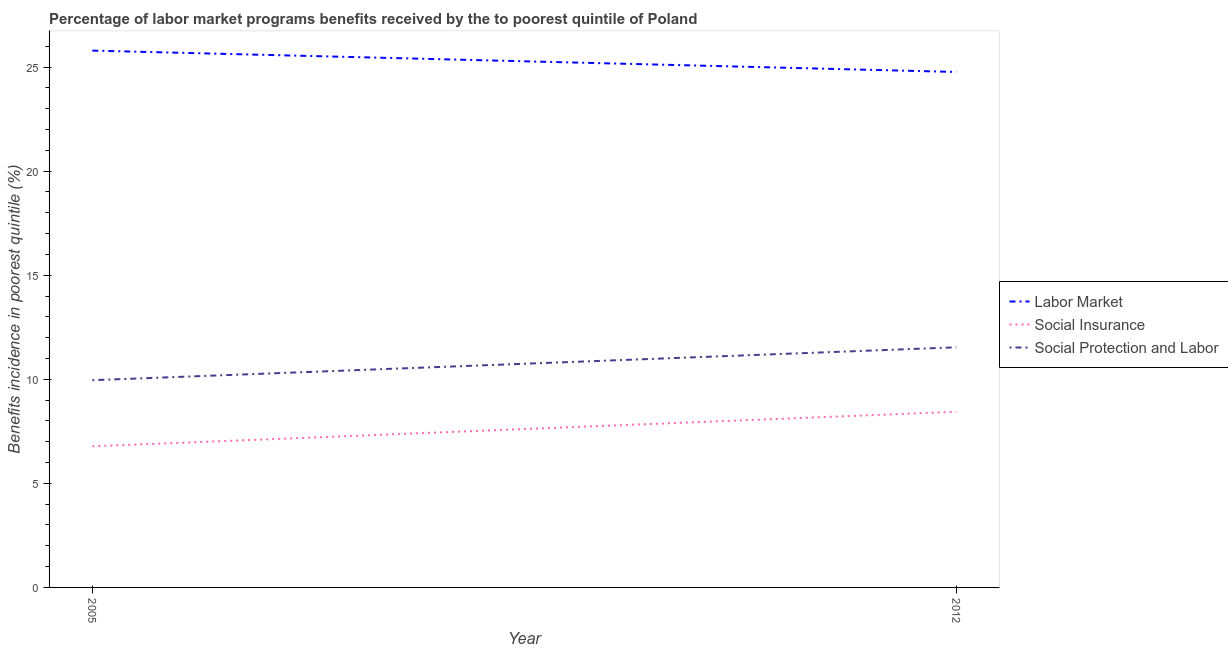Is the number of lines equal to the number of legend labels?
Provide a succinct answer. Yes. What is the percentage of benefits received due to labor market programs in 2005?
Your response must be concise. 25.79. Across all years, what is the maximum percentage of benefits received due to social protection programs?
Provide a succinct answer. 11.54. Across all years, what is the minimum percentage of benefits received due to social insurance programs?
Offer a terse response. 6.78. In which year was the percentage of benefits received due to social insurance programs maximum?
Your response must be concise. 2012. What is the total percentage of benefits received due to labor market programs in the graph?
Keep it short and to the point. 50.55. What is the difference between the percentage of benefits received due to social insurance programs in 2005 and that in 2012?
Your answer should be compact. -1.66. What is the difference between the percentage of benefits received due to social insurance programs in 2012 and the percentage of benefits received due to social protection programs in 2005?
Provide a short and direct response. -1.52. What is the average percentage of benefits received due to social protection programs per year?
Give a very brief answer. 10.75. In the year 2005, what is the difference between the percentage of benefits received due to labor market programs and percentage of benefits received due to social insurance programs?
Provide a succinct answer. 19.01. What is the ratio of the percentage of benefits received due to social insurance programs in 2005 to that in 2012?
Your answer should be compact. 0.8. Is the percentage of benefits received due to social protection programs in 2005 less than that in 2012?
Offer a very short reply. Yes. In how many years, is the percentage of benefits received due to social protection programs greater than the average percentage of benefits received due to social protection programs taken over all years?
Make the answer very short. 1. Is it the case that in every year, the sum of the percentage of benefits received due to labor market programs and percentage of benefits received due to social insurance programs is greater than the percentage of benefits received due to social protection programs?
Keep it short and to the point. Yes. Does the percentage of benefits received due to social protection programs monotonically increase over the years?
Your answer should be very brief. Yes. Is the percentage of benefits received due to social protection programs strictly greater than the percentage of benefits received due to social insurance programs over the years?
Offer a terse response. Yes. What is the difference between two consecutive major ticks on the Y-axis?
Your answer should be compact. 5. Are the values on the major ticks of Y-axis written in scientific E-notation?
Offer a very short reply. No. Does the graph contain any zero values?
Ensure brevity in your answer.  No. How many legend labels are there?
Your answer should be very brief. 3. What is the title of the graph?
Make the answer very short. Percentage of labor market programs benefits received by the to poorest quintile of Poland. What is the label or title of the X-axis?
Offer a terse response. Year. What is the label or title of the Y-axis?
Give a very brief answer. Benefits incidence in poorest quintile (%). What is the Benefits incidence in poorest quintile (%) of Labor Market in 2005?
Ensure brevity in your answer.  25.79. What is the Benefits incidence in poorest quintile (%) in Social Insurance in 2005?
Ensure brevity in your answer.  6.78. What is the Benefits incidence in poorest quintile (%) of Social Protection and Labor in 2005?
Provide a short and direct response. 9.96. What is the Benefits incidence in poorest quintile (%) of Labor Market in 2012?
Ensure brevity in your answer.  24.76. What is the Benefits incidence in poorest quintile (%) in Social Insurance in 2012?
Provide a succinct answer. 8.44. What is the Benefits incidence in poorest quintile (%) of Social Protection and Labor in 2012?
Your answer should be very brief. 11.54. Across all years, what is the maximum Benefits incidence in poorest quintile (%) in Labor Market?
Ensure brevity in your answer.  25.79. Across all years, what is the maximum Benefits incidence in poorest quintile (%) in Social Insurance?
Ensure brevity in your answer.  8.44. Across all years, what is the maximum Benefits incidence in poorest quintile (%) of Social Protection and Labor?
Provide a short and direct response. 11.54. Across all years, what is the minimum Benefits incidence in poorest quintile (%) of Labor Market?
Your answer should be very brief. 24.76. Across all years, what is the minimum Benefits incidence in poorest quintile (%) in Social Insurance?
Ensure brevity in your answer.  6.78. Across all years, what is the minimum Benefits incidence in poorest quintile (%) of Social Protection and Labor?
Make the answer very short. 9.96. What is the total Benefits incidence in poorest quintile (%) of Labor Market in the graph?
Keep it short and to the point. 50.55. What is the total Benefits incidence in poorest quintile (%) of Social Insurance in the graph?
Provide a succinct answer. 15.22. What is the total Benefits incidence in poorest quintile (%) in Social Protection and Labor in the graph?
Your answer should be very brief. 21.49. What is the difference between the Benefits incidence in poorest quintile (%) in Labor Market in 2005 and that in 2012?
Offer a terse response. 1.03. What is the difference between the Benefits incidence in poorest quintile (%) of Social Insurance in 2005 and that in 2012?
Provide a succinct answer. -1.66. What is the difference between the Benefits incidence in poorest quintile (%) in Social Protection and Labor in 2005 and that in 2012?
Ensure brevity in your answer.  -1.58. What is the difference between the Benefits incidence in poorest quintile (%) of Labor Market in 2005 and the Benefits incidence in poorest quintile (%) of Social Insurance in 2012?
Make the answer very short. 17.35. What is the difference between the Benefits incidence in poorest quintile (%) of Labor Market in 2005 and the Benefits incidence in poorest quintile (%) of Social Protection and Labor in 2012?
Provide a short and direct response. 14.25. What is the difference between the Benefits incidence in poorest quintile (%) of Social Insurance in 2005 and the Benefits incidence in poorest quintile (%) of Social Protection and Labor in 2012?
Offer a terse response. -4.76. What is the average Benefits incidence in poorest quintile (%) in Labor Market per year?
Your response must be concise. 25.28. What is the average Benefits incidence in poorest quintile (%) of Social Insurance per year?
Ensure brevity in your answer.  7.61. What is the average Benefits incidence in poorest quintile (%) in Social Protection and Labor per year?
Make the answer very short. 10.75. In the year 2005, what is the difference between the Benefits incidence in poorest quintile (%) of Labor Market and Benefits incidence in poorest quintile (%) of Social Insurance?
Your answer should be compact. 19.01. In the year 2005, what is the difference between the Benefits incidence in poorest quintile (%) of Labor Market and Benefits incidence in poorest quintile (%) of Social Protection and Labor?
Your answer should be compact. 15.83. In the year 2005, what is the difference between the Benefits incidence in poorest quintile (%) in Social Insurance and Benefits incidence in poorest quintile (%) in Social Protection and Labor?
Offer a terse response. -3.18. In the year 2012, what is the difference between the Benefits incidence in poorest quintile (%) of Labor Market and Benefits incidence in poorest quintile (%) of Social Insurance?
Ensure brevity in your answer.  16.32. In the year 2012, what is the difference between the Benefits incidence in poorest quintile (%) of Labor Market and Benefits incidence in poorest quintile (%) of Social Protection and Labor?
Give a very brief answer. 13.23. In the year 2012, what is the difference between the Benefits incidence in poorest quintile (%) in Social Insurance and Benefits incidence in poorest quintile (%) in Social Protection and Labor?
Make the answer very short. -3.1. What is the ratio of the Benefits incidence in poorest quintile (%) of Labor Market in 2005 to that in 2012?
Give a very brief answer. 1.04. What is the ratio of the Benefits incidence in poorest quintile (%) of Social Insurance in 2005 to that in 2012?
Your response must be concise. 0.8. What is the ratio of the Benefits incidence in poorest quintile (%) of Social Protection and Labor in 2005 to that in 2012?
Ensure brevity in your answer.  0.86. What is the difference between the highest and the second highest Benefits incidence in poorest quintile (%) of Labor Market?
Ensure brevity in your answer.  1.03. What is the difference between the highest and the second highest Benefits incidence in poorest quintile (%) in Social Insurance?
Your answer should be very brief. 1.66. What is the difference between the highest and the second highest Benefits incidence in poorest quintile (%) in Social Protection and Labor?
Your answer should be very brief. 1.58. What is the difference between the highest and the lowest Benefits incidence in poorest quintile (%) in Labor Market?
Your response must be concise. 1.03. What is the difference between the highest and the lowest Benefits incidence in poorest quintile (%) in Social Insurance?
Offer a terse response. 1.66. What is the difference between the highest and the lowest Benefits incidence in poorest quintile (%) of Social Protection and Labor?
Give a very brief answer. 1.58. 